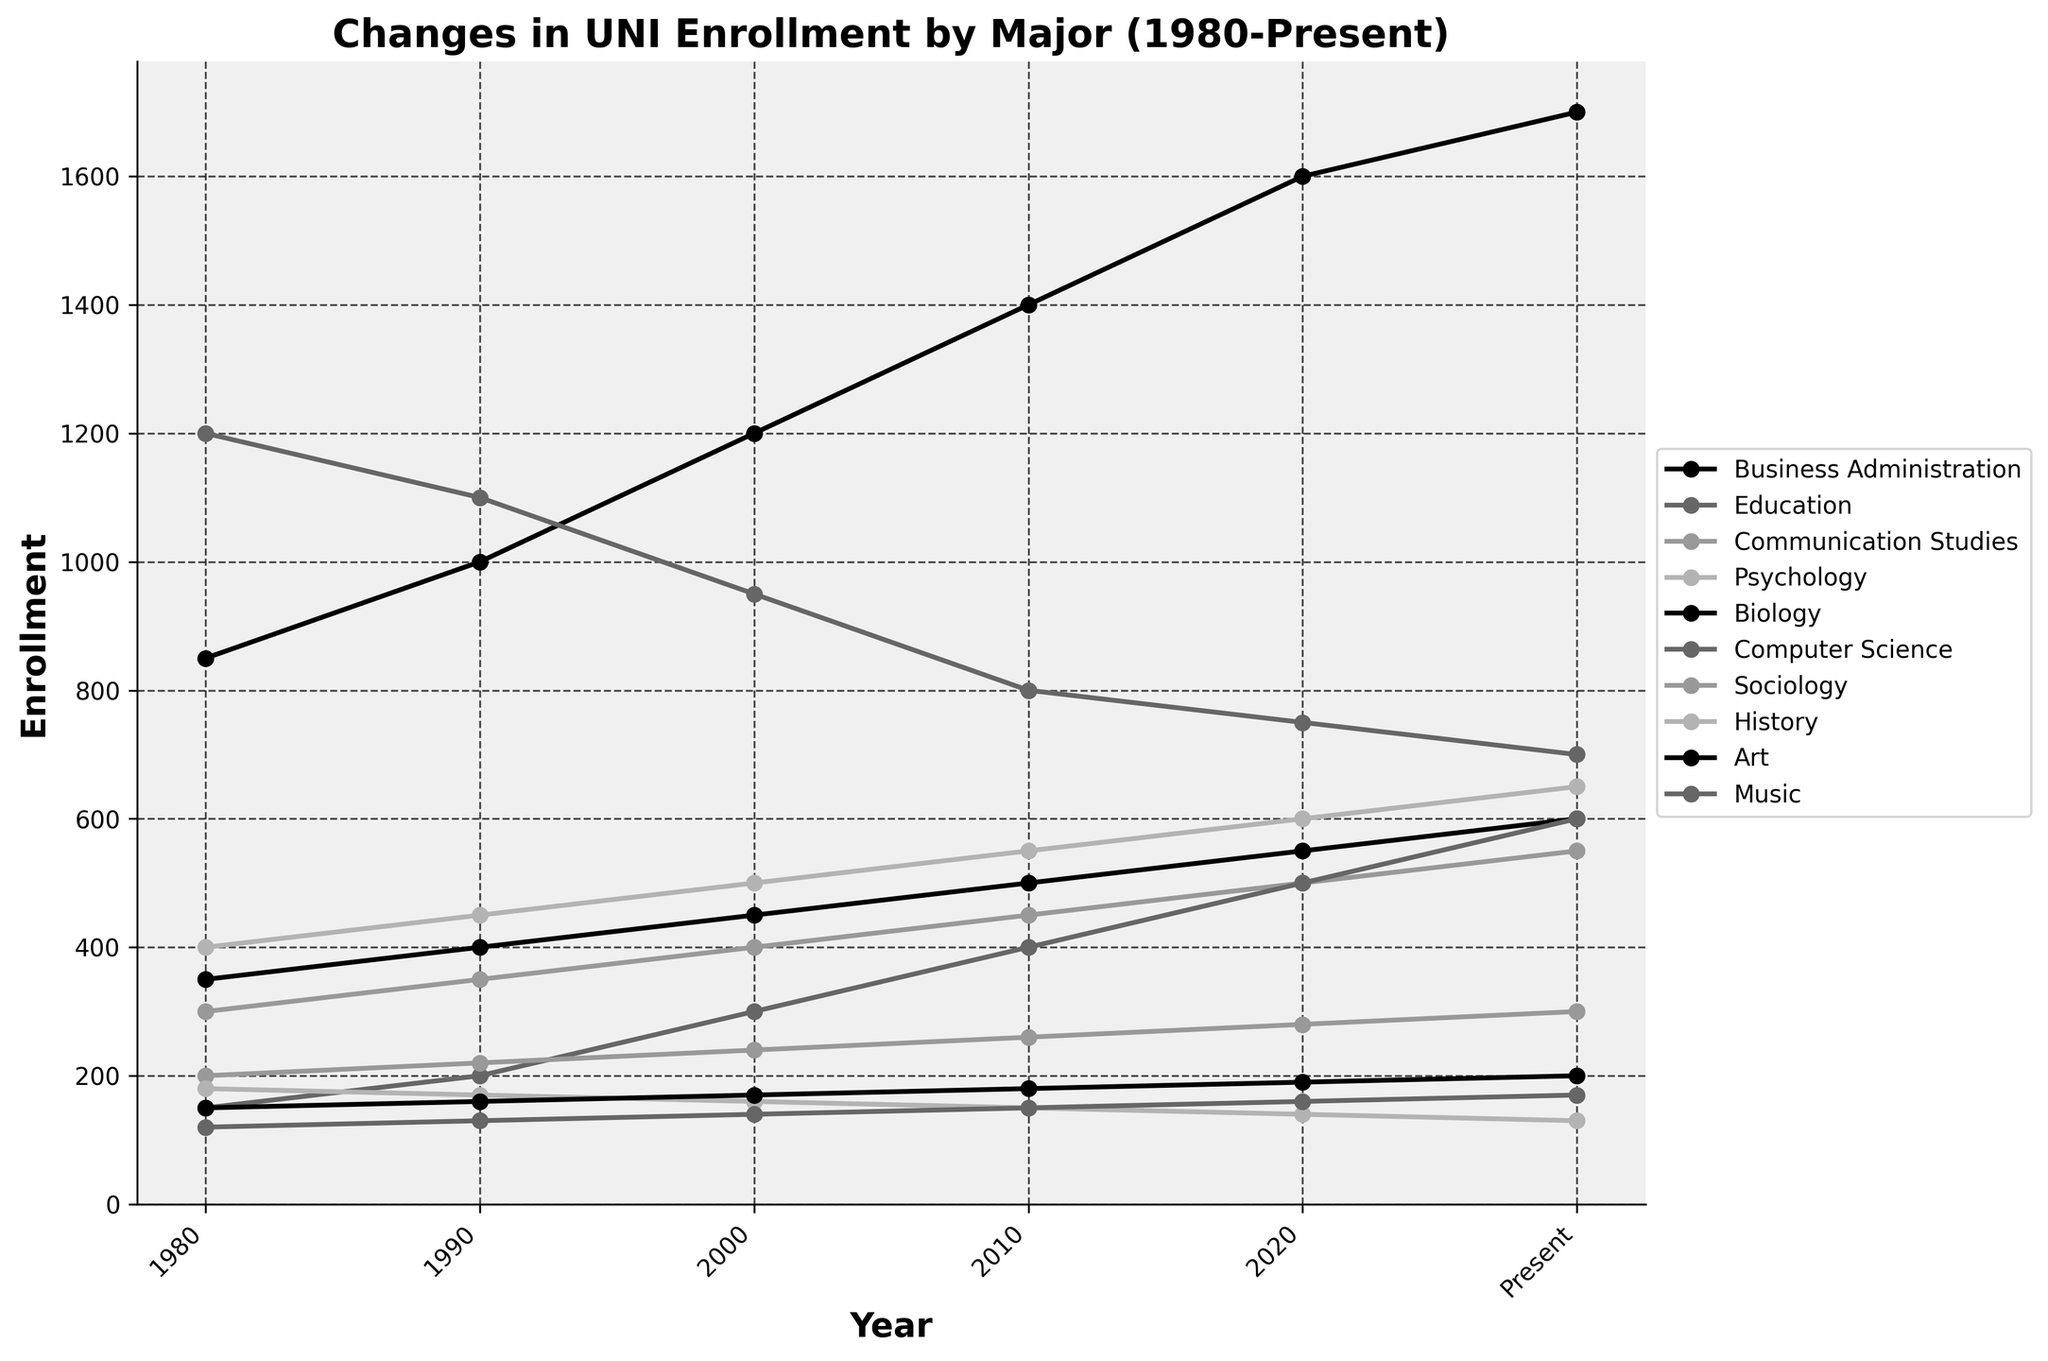When did Business Administration first surpass 1400 enrollment? Looking at the Business Administration line, it first surpasses 1400 in 2010.
Answer: 2010 Which major had the highest enrollment in 1980? By comparing the enrollment values for 1980 across all majors, Education had the highest enrollment with 1200.
Answer: Education What is the total enrollment for Music from 1980 to Present? Sum up the enrollment of Music across all years: 120 + 130 + 140 + 150 + 160 + 170 = 870.
Answer: 870 How many majors have seen a consistent increase in enrollment from 1980 to Present? Observing the trends, Business Administration, Psychology, Biology, Computer Science, and Music show consistent increases.
Answer: 5 Which major had the largest drop in enrollment from 1980 to present? By comparing the differences in enrollment from 1980 to present, Education dropped from 1200 to 700, a drop of 500.
Answer: Education How does the trend of Computer Science compare to that of History? Computer Science started lower than History in 1980 but surpassed it by 2000 and continued to rise whereas History consistently declined.
Answer: Computer Science increased; History decreased What is the average enrollment for Psychology from 1980 to Present? Sum the enrollments for Psychology: 400 + 450 + 500 + 550 + 600 + 650 = 3150. Divide by 6: 3150 / 6 = 525.
Answer: 525 Which two majors had enrollments closest to each other in 2020? By comparing 2020 enrollments: Education (750) and Communication Studies (500) are closest, differing by only 50.
Answer: Communication Studies and Psychology What is the general trend for Art enrollment from 1980 to present? The plot line for Art shows a very gradual increase from 150 in 1980 to 200 in present.
Answer: Gradual increase Was there any major that had a decreasing trend, then an increasing trend, then decreasing again? Sociology shows a decrease from 1980 to 1990, an increase until 2020, and then a decrease to present.
Answer: Sociology 